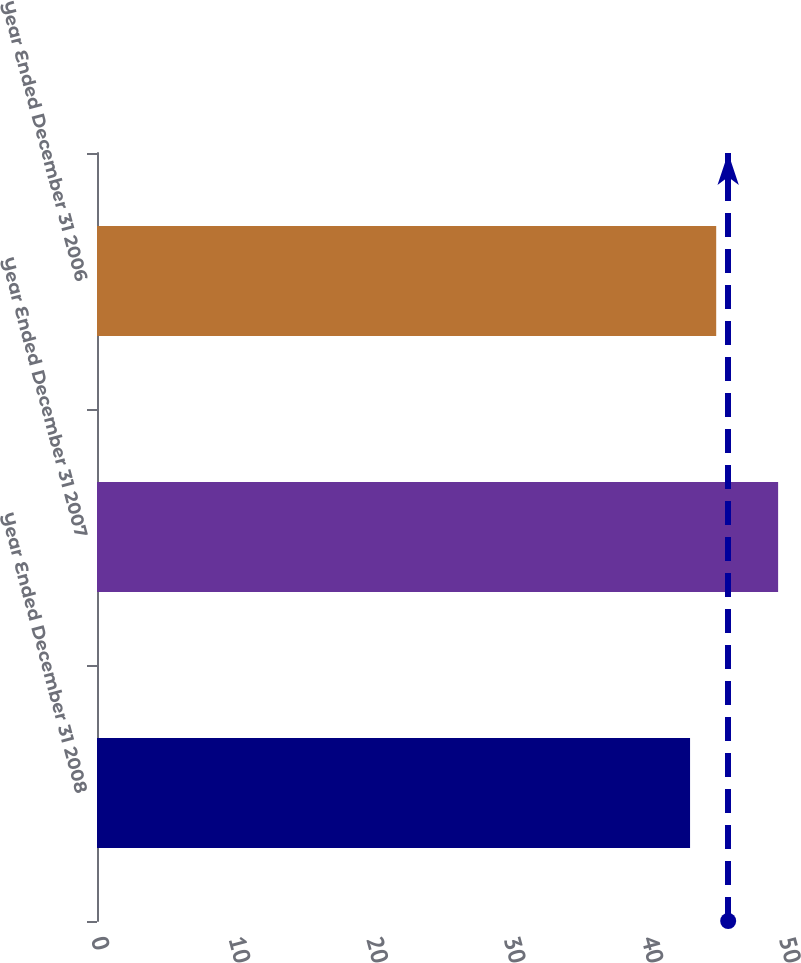Convert chart. <chart><loc_0><loc_0><loc_500><loc_500><bar_chart><fcel>Year Ended December 31 2008<fcel>Year Ended December 31 2007<fcel>Year Ended December 31 2006<nl><fcel>43.1<fcel>49.5<fcel>45<nl></chart> 